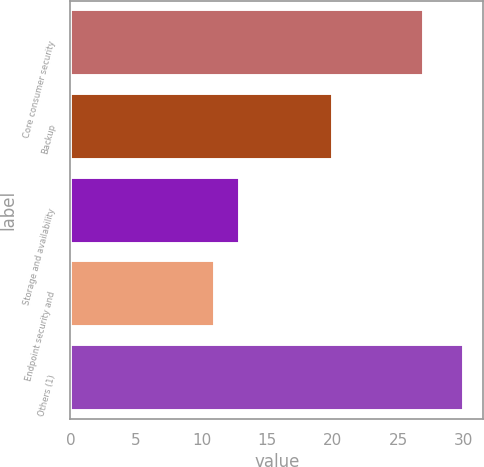<chart> <loc_0><loc_0><loc_500><loc_500><bar_chart><fcel>Core consumer security<fcel>Backup<fcel>Storage and availability<fcel>Endpoint security and<fcel>Others (1)<nl><fcel>27<fcel>20<fcel>12.9<fcel>11<fcel>30<nl></chart> 